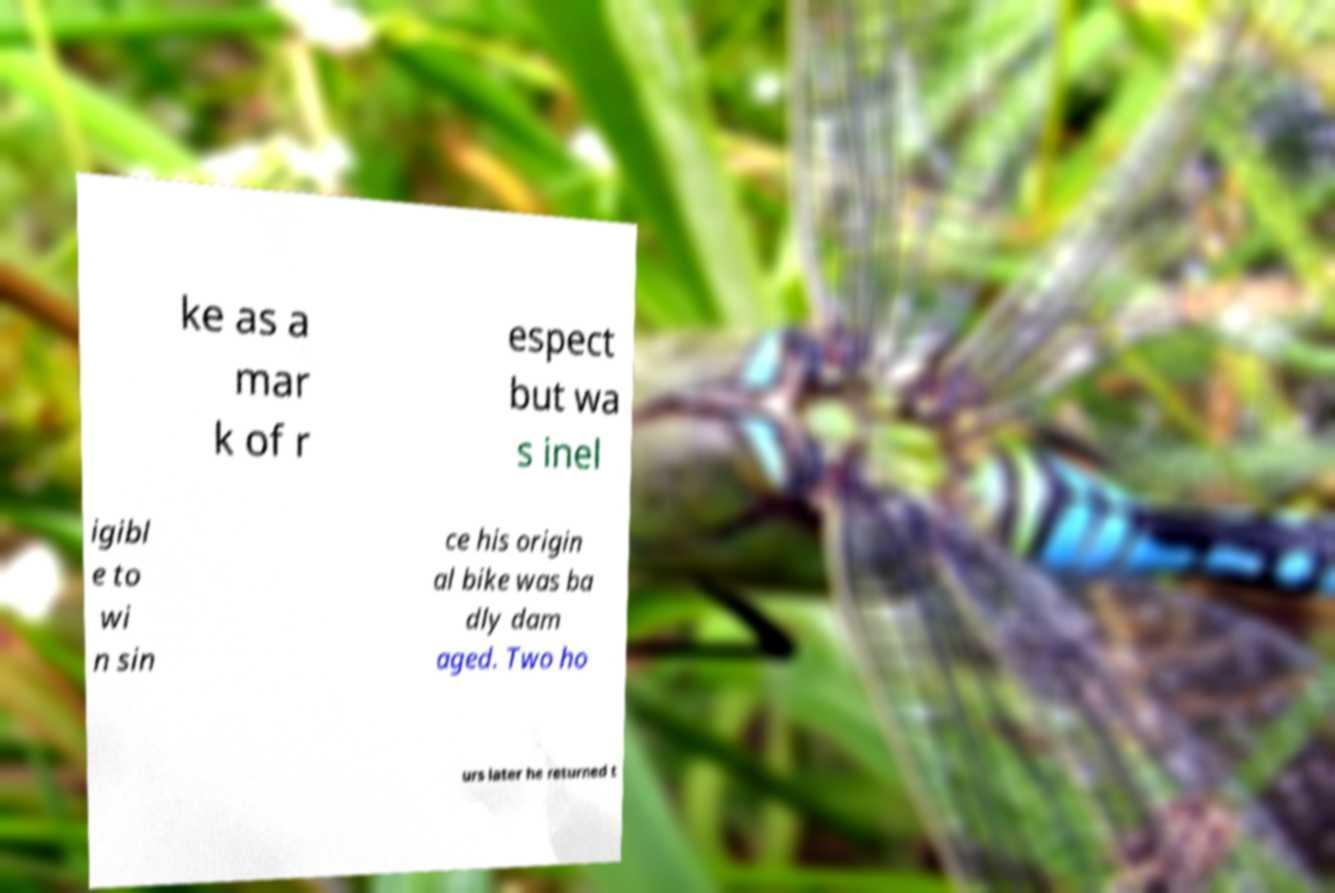For documentation purposes, I need the text within this image transcribed. Could you provide that? ke as a mar k of r espect but wa s inel igibl e to wi n sin ce his origin al bike was ba dly dam aged. Two ho urs later he returned t 